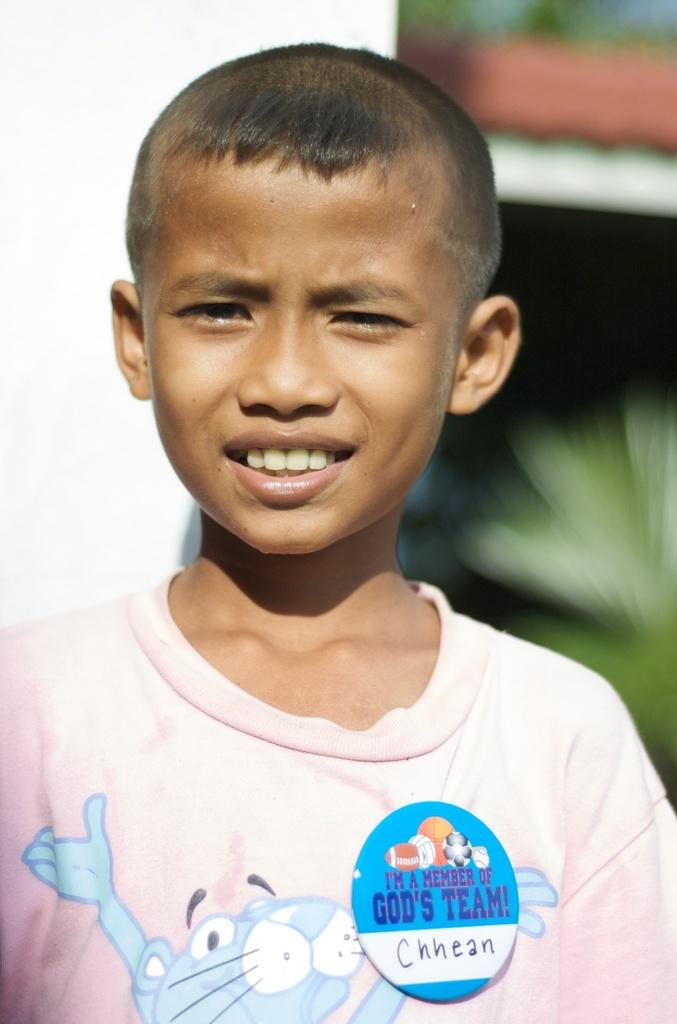Who is the main subject in the image? There is a boy in the image. What is the boy doing in the image? The boy is smiling. What can be seen in the background of the image? There is a house behind the boy. What type of authority does the boy have in the image? There is no indication of any authority in the image; it simply shows a boy smiling. 